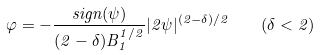<formula> <loc_0><loc_0><loc_500><loc_500>\varphi = - \frac { s i g n ( \psi ) } { ( 2 - \delta ) B _ { 1 } ^ { 1 / 2 } } | 2 \psi | ^ { ( 2 - \delta ) / 2 } \quad ( \delta < 2 )</formula> 